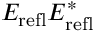Convert formula to latex. <formula><loc_0><loc_0><loc_500><loc_500>E _ { r e f l } E _ { r e f l } ^ { * }</formula> 